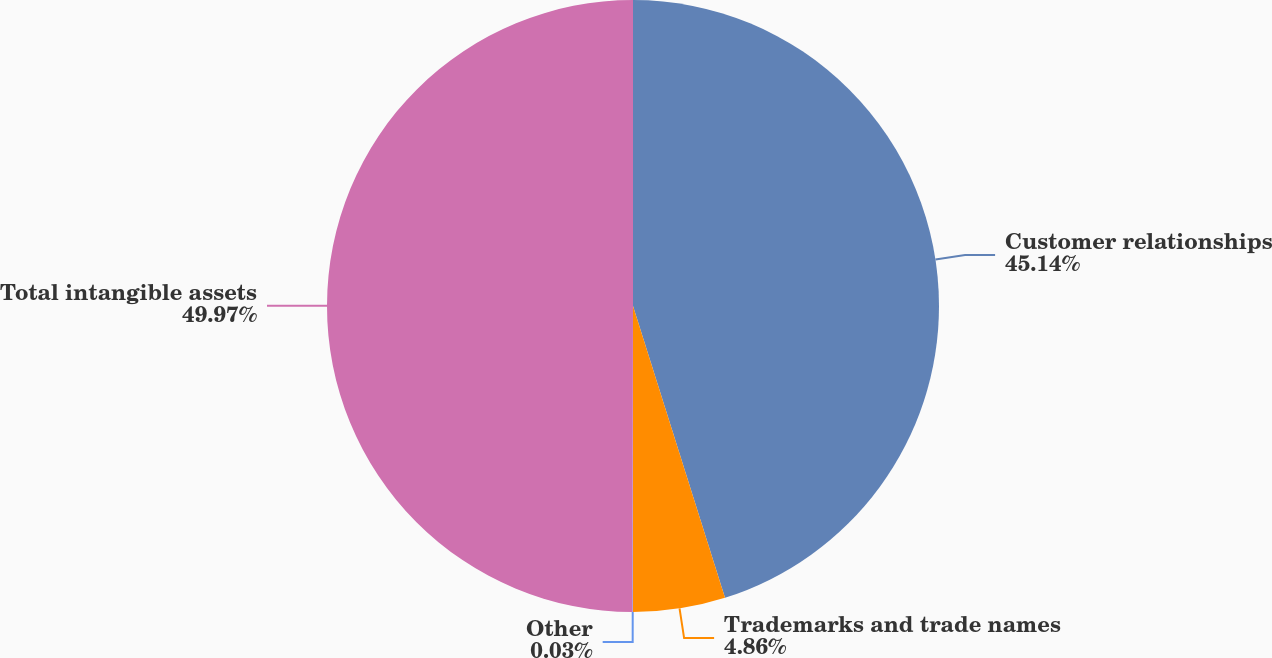Convert chart to OTSL. <chart><loc_0><loc_0><loc_500><loc_500><pie_chart><fcel>Customer relationships<fcel>Trademarks and trade names<fcel>Other<fcel>Total intangible assets<nl><fcel>45.14%<fcel>4.86%<fcel>0.03%<fcel>49.97%<nl></chart> 